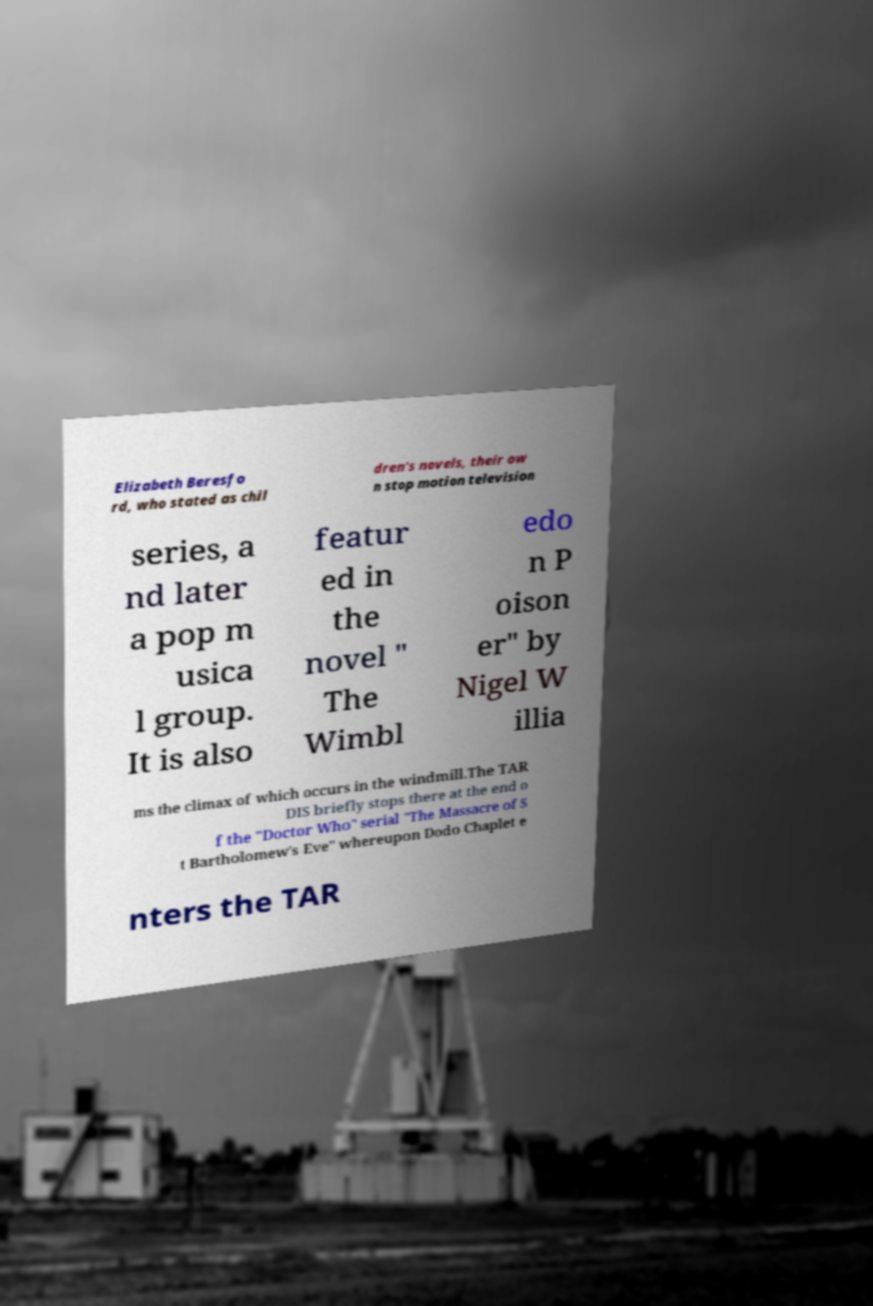Please read and relay the text visible in this image. What does it say? Elizabeth Beresfo rd, who stated as chil dren's novels, their ow n stop motion television series, a nd later a pop m usica l group. It is also featur ed in the novel " The Wimbl edo n P oison er" by Nigel W illia ms the climax of which occurs in the windmill.The TAR DIS briefly stops there at the end o f the "Doctor Who" serial "The Massacre of S t Bartholomew's Eve" whereupon Dodo Chaplet e nters the TAR 